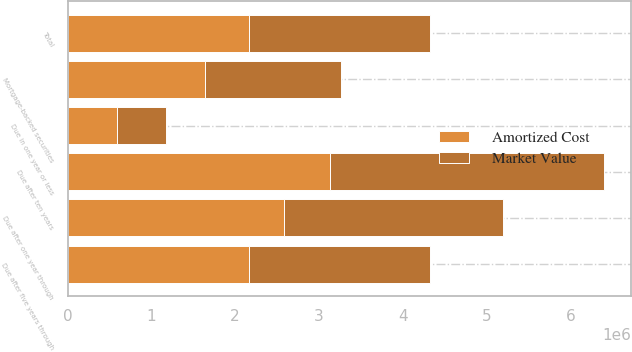Convert chart to OTSL. <chart><loc_0><loc_0><loc_500><loc_500><stacked_bar_chart><ecel><fcel>Due in one year or less<fcel>Due after one year through<fcel>Due after five years through<fcel>Due after ten years<fcel>Mortgage-backed securities<fcel>Total<nl><fcel>Amortized Cost<fcel>585207<fcel>2.58841e+06<fcel>2.16819e+06<fcel>3.13801e+06<fcel>1.63654e+06<fcel>2.16469e+06<nl><fcel>Market Value<fcel>585773<fcel>2.60774e+06<fcel>2.16118e+06<fcel>3.26366e+06<fcel>1.62724e+06<fcel>2.16469e+06<nl></chart> 